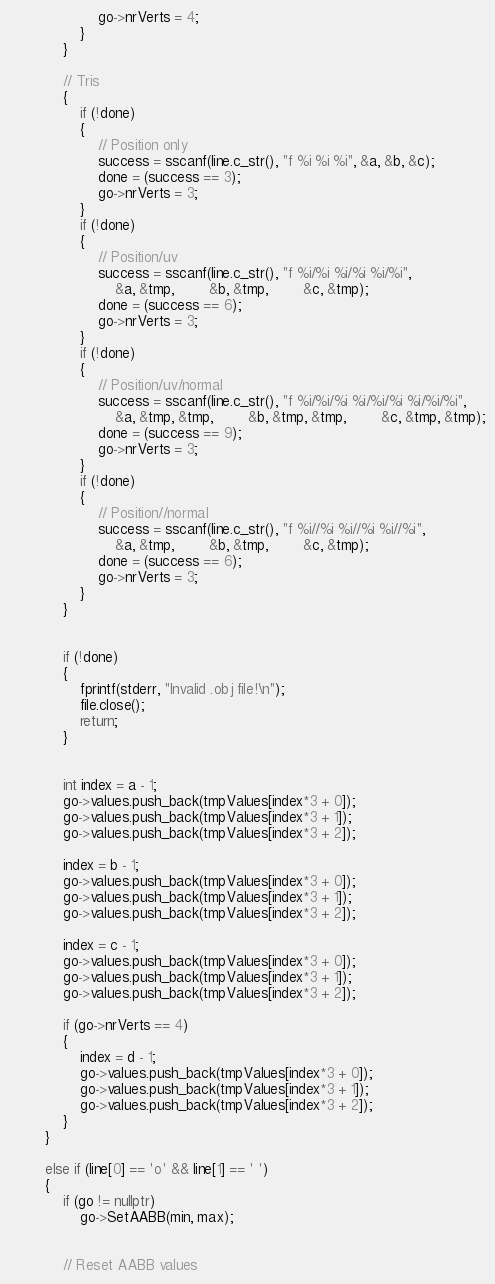<code> <loc_0><loc_0><loc_500><loc_500><_C++_>					go->nrVerts = 4;
				}
			}

			// Tris
			{
				if (!done)
				{
					// Position only
					success = sscanf(line.c_str(), "f %i %i %i", &a, &b, &c);
					done = (success == 3);
					go->nrVerts = 3;
				}
				if (!done)
				{
					// Position/uv
					success = sscanf(line.c_str(), "f %i/%i %i/%i %i/%i",
						&a, &tmp,		&b, &tmp,		&c, &tmp);
					done = (success == 6);
					go->nrVerts = 3;
				}
				if (!done)
				{
					// Position/uv/normal
					success = sscanf(line.c_str(), "f %i/%i/%i %i/%i/%i %i/%i/%i",
						&a, &tmp, &tmp,		&b, &tmp, &tmp,		&c, &tmp, &tmp);
					done = (success == 9);
					go->nrVerts = 3;
				}
				if (!done)
				{
					// Position//normal
					success = sscanf(line.c_str(), "f %i//%i %i//%i %i//%i",
						&a, &tmp,		&b, &tmp, 		&c, &tmp);
					done = (success == 6);
					go->nrVerts = 3;
				}
			}


			if (!done)
			{
				fprintf(stderr, "Invalid .obj file!\n");
				file.close();
				return;
			}
			

			int index = a - 1;
			go->values.push_back(tmpValues[index*3 + 0]);
			go->values.push_back(tmpValues[index*3 + 1]);
			go->values.push_back(tmpValues[index*3 + 2]);

			index = b - 1;
			go->values.push_back(tmpValues[index*3 + 0]);
			go->values.push_back(tmpValues[index*3 + 1]);
			go->values.push_back(tmpValues[index*3 + 2]);

			index = c - 1;
			go->values.push_back(tmpValues[index*3 + 0]);
			go->values.push_back(tmpValues[index*3 + 1]);
			go->values.push_back(tmpValues[index*3 + 2]);

			if (go->nrVerts == 4)
			{
				index = d - 1;
				go->values.push_back(tmpValues[index*3 + 0]);
				go->values.push_back(tmpValues[index*3 + 1]);
				go->values.push_back(tmpValues[index*3 + 2]);
			}
		}

		else if (line[0] == 'o' && line[1] == ' ')
		{
			if (go != nullptr)
				go->SetAABB(min, max);
			
			
			// Reset AABB values</code> 